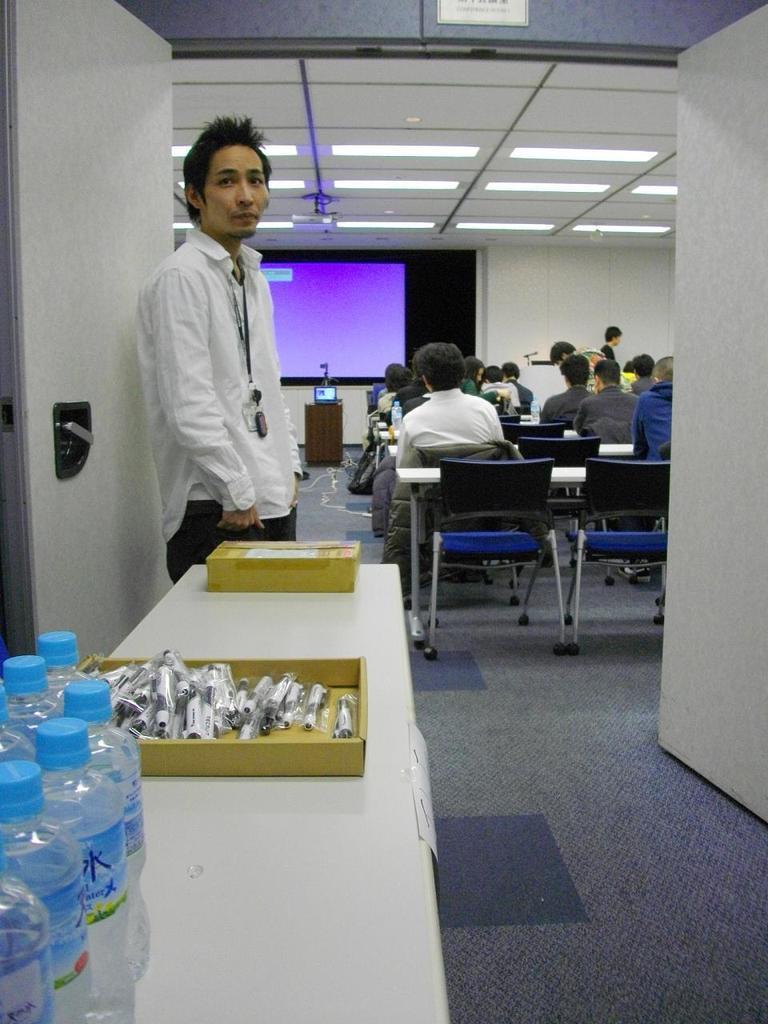Please provide a concise description of this image. In this image i can see a man is standing. I can also see a group of people who are sitting on a chair in front of a board. there is a table with few bottles and other objects on it. 